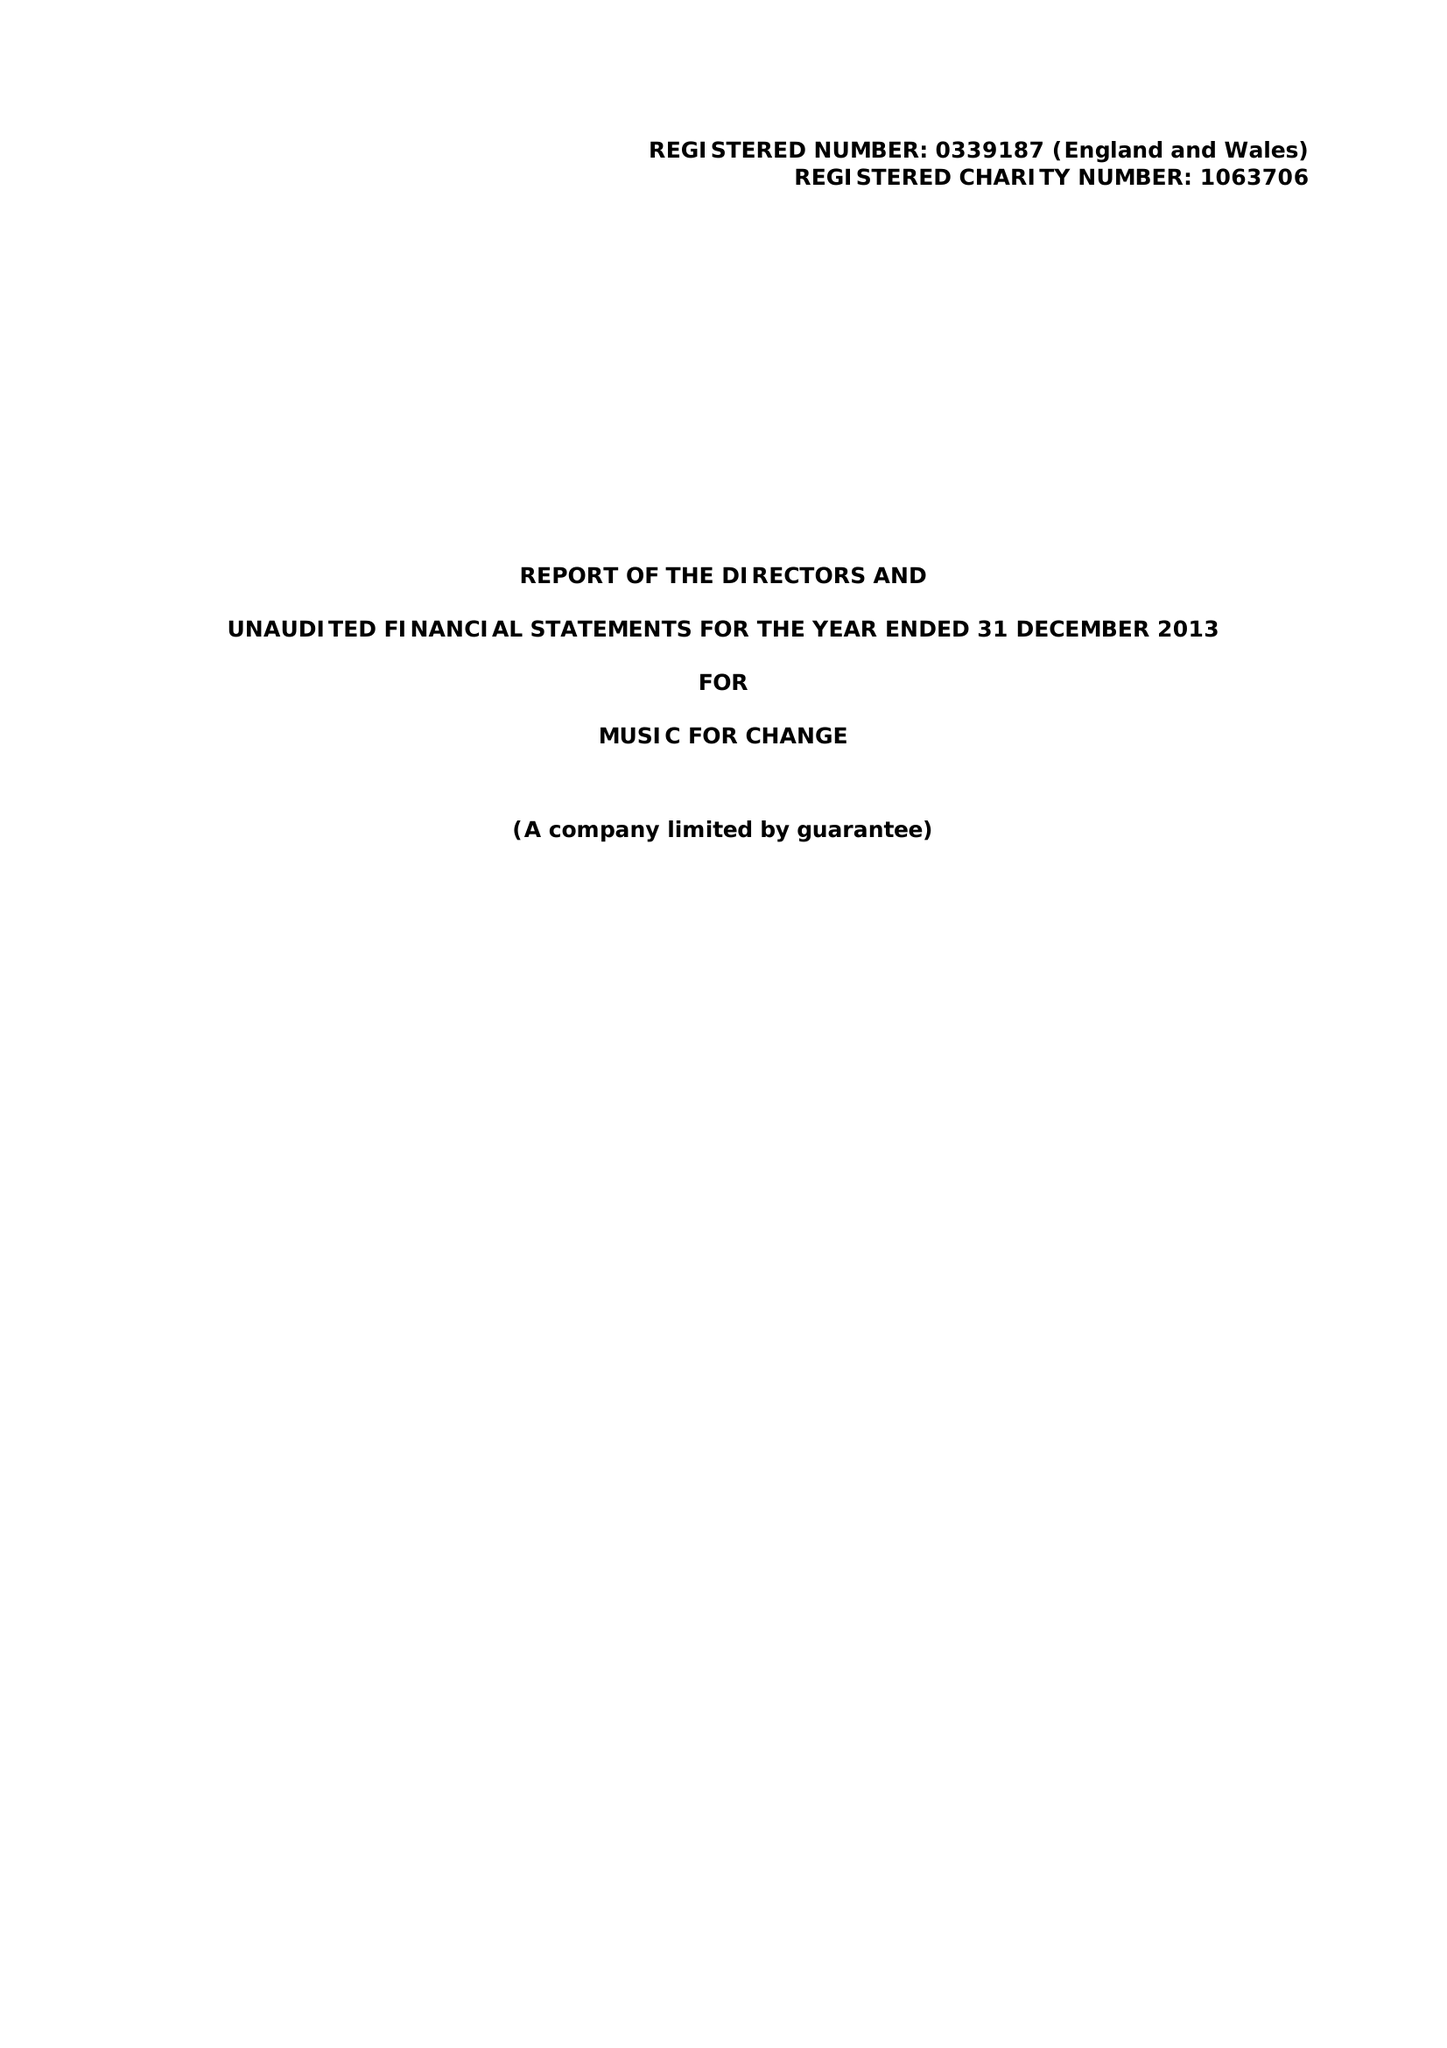What is the value for the address__post_town?
Answer the question using a single word or phrase. CANTERBURY 